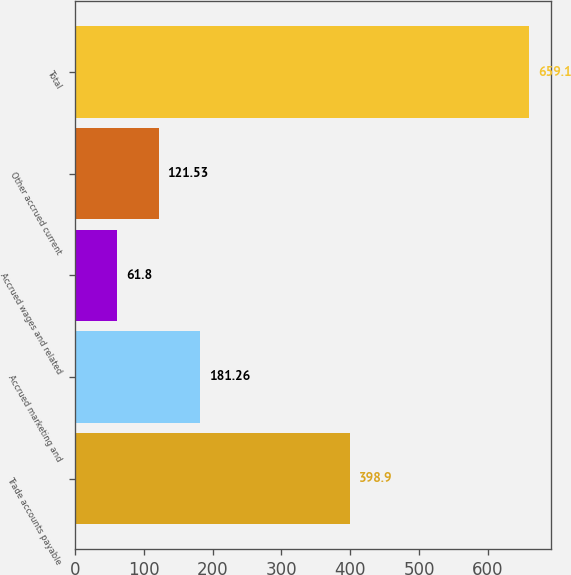Convert chart. <chart><loc_0><loc_0><loc_500><loc_500><bar_chart><fcel>Trade accounts payable<fcel>Accrued marketing and<fcel>Accrued wages and related<fcel>Other accrued current<fcel>Total<nl><fcel>398.9<fcel>181.26<fcel>61.8<fcel>121.53<fcel>659.1<nl></chart> 